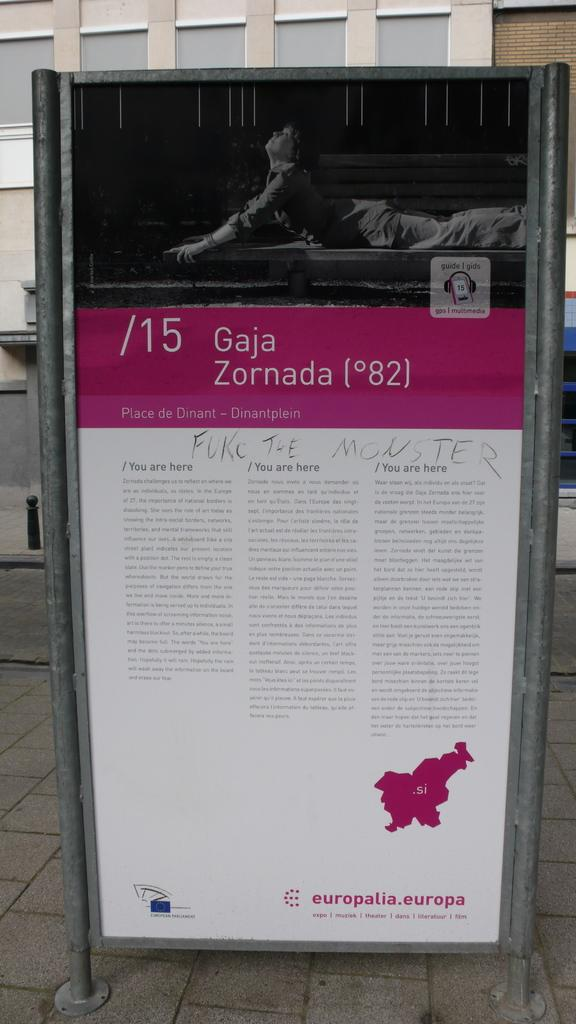What is the main object in the image? There is a board in the image. What is happening with the person in the image? A person is lying on the board. What can be seen on the board besides the person? There is text written on the board. What can be seen in the distance in the image? There is a building visible in the background of the image. What type of respect is being shown by the porter in the image? There is no porter present in the image, and therefore no such interaction can be observed. 